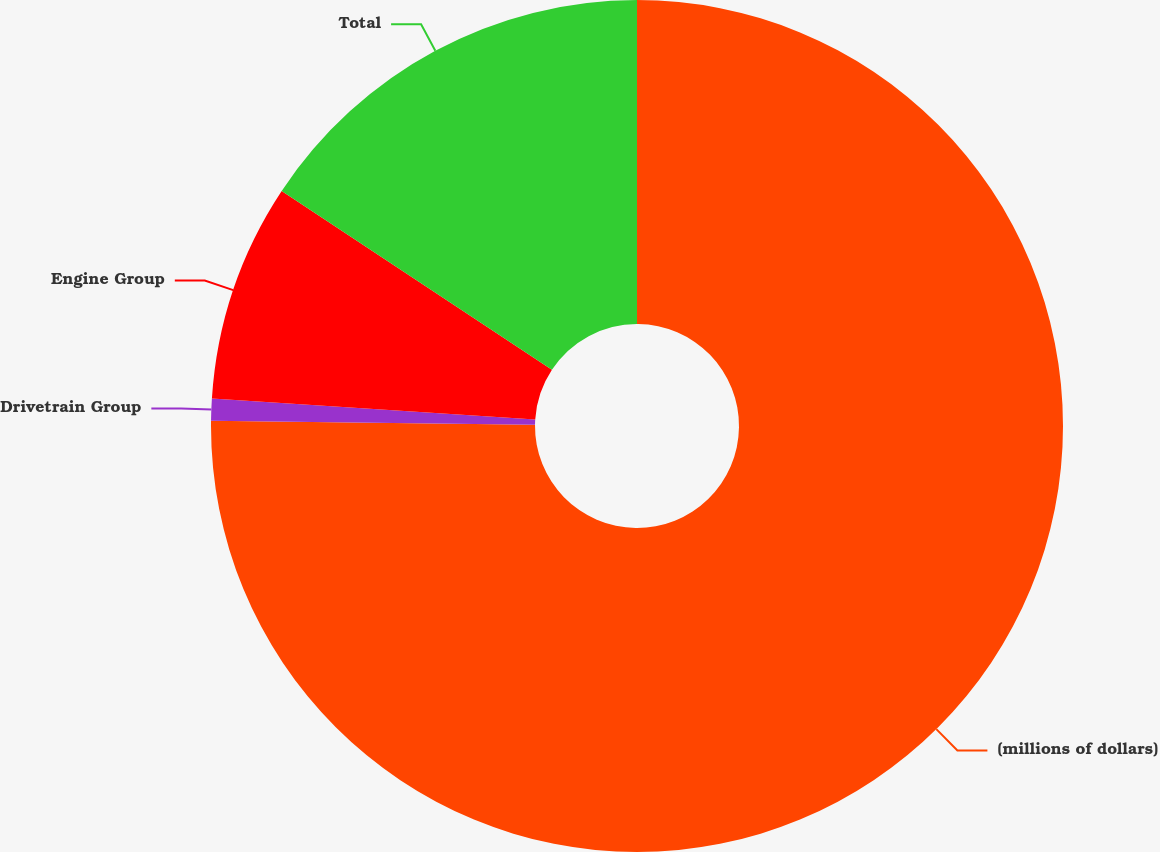Convert chart. <chart><loc_0><loc_0><loc_500><loc_500><pie_chart><fcel>(millions of dollars)<fcel>Drivetrain Group<fcel>Engine Group<fcel>Total<nl><fcel>75.2%<fcel>0.83%<fcel>8.27%<fcel>15.7%<nl></chart> 